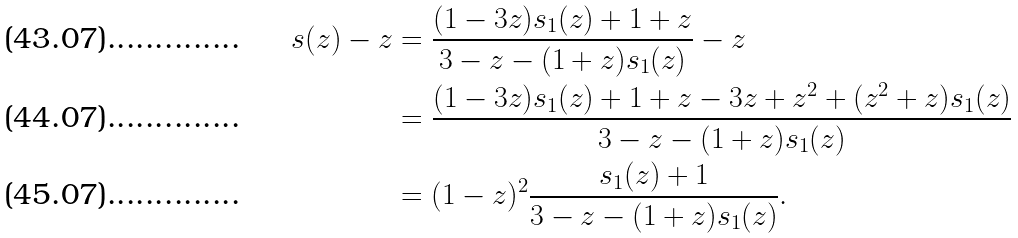<formula> <loc_0><loc_0><loc_500><loc_500>s ( z ) - z & = \frac { ( 1 - 3 z ) s _ { 1 } ( z ) + 1 + z } { 3 - z - ( 1 + z ) s _ { 1 } ( z ) } - z \\ & = \frac { ( 1 - 3 z ) s _ { 1 } ( z ) + 1 + z - 3 z + z ^ { 2 } + ( z ^ { 2 } + z ) s _ { 1 } ( z ) } { 3 - z - ( 1 + z ) s _ { 1 } ( z ) } \\ & = ( 1 - z ) ^ { 2 } \frac { s _ { 1 } ( z ) + 1 } { 3 - z - ( 1 + z ) s _ { 1 } ( z ) } .</formula> 